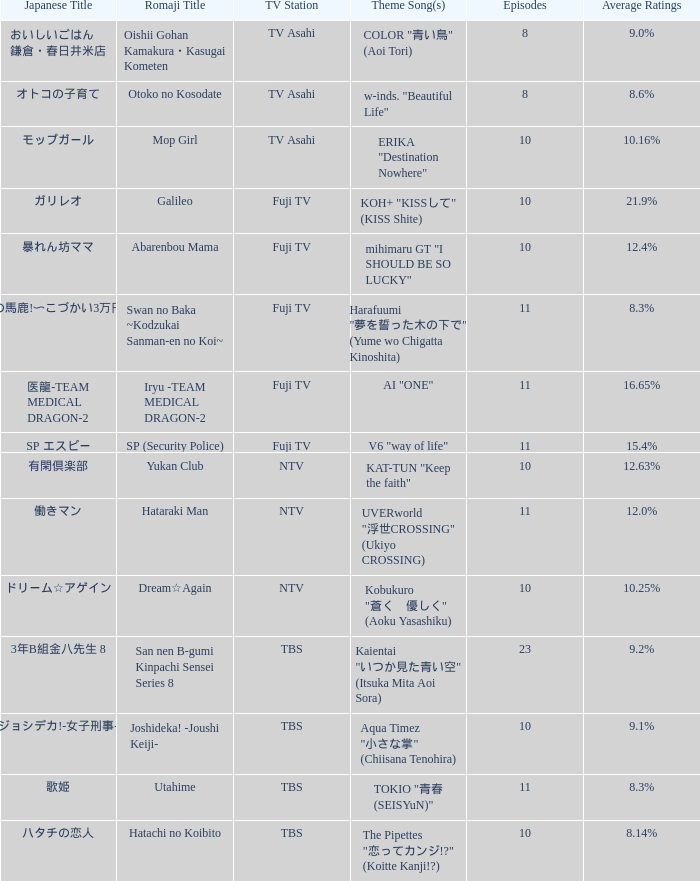Could you help me parse every detail presented in this table? {'header': ['Japanese Title', 'Romaji Title', 'TV Station', 'Theme Song(s)', 'Episodes', 'Average Ratings'], 'rows': [['おいしいごはん 鎌倉・春日井米店', 'Oishii Gohan Kamakura・Kasugai Kometen', 'TV Asahi', 'COLOR "青い鳥" (Aoi Tori)', '8', '9.0%'], ['オトコの子育て', 'Otoko no Kosodate', 'TV Asahi', 'w-inds. "Beautiful Life"', '8', '8.6%'], ['モップガール', 'Mop Girl', 'TV Asahi', 'ERIKA "Destination Nowhere"', '10', '10.16%'], ['ガリレオ', 'Galileo', 'Fuji TV', 'KOH+ "KISSして" (KISS Shite)', '10', '21.9%'], ['暴れん坊ママ', 'Abarenbou Mama', 'Fuji TV', 'mihimaru GT "I SHOULD BE SO LUCKY"', '10', '12.4%'], ['スワンの馬鹿!〜こづかい3万円の恋〜', 'Swan no Baka ~Kodzukai Sanman-en no Koi~', 'Fuji TV', 'Harafuumi "夢を誓った木の下で" (Yume wo Chigatta Kinoshita)', '11', '8.3%'], ['医龍-TEAM MEDICAL DRAGON-2', 'Iryu -TEAM MEDICAL DRAGON-2', 'Fuji TV', 'AI "ONE"', '11', '16.65%'], ['SP エスピー', 'SP (Security Police)', 'Fuji TV', 'V6 "way of life"', '11', '15.4%'], ['有閑倶楽部', 'Yukan Club', 'NTV', 'KAT-TUN "Keep the faith"', '10', '12.63%'], ['働きマン', 'Hataraki Man', 'NTV', 'UVERworld "浮世CROSSING" (Ukiyo CROSSING)', '11', '12.0%'], ['ドリーム☆アゲイン', 'Dream☆Again', 'NTV', 'Kobukuro "蒼く\u3000優しく" (Aoku Yasashiku)', '10', '10.25%'], ['3年B組金八先生 8', 'San nen B-gumi Kinpachi Sensei Series 8', 'TBS', 'Kaientai "いつか見た青い空" (Itsuka Mita Aoi Sora)', '23', '9.2%'], ['ジョシデカ!-女子刑事-', 'Joshideka! -Joushi Keiji-', 'TBS', 'Aqua Timez "小さな掌" (Chiisana Tenohira)', '10', '9.1%'], ['歌姫', 'Utahime', 'TBS', 'TOKIO "青春 (SEISYuN)"', '11', '8.3%'], ['ハタチの恋人', 'Hatachi no Koibito', 'TBS', 'The Pipettes "恋ってカンジ!?" (Koitte Kanji!?)', '10', '8.14%']]} Which song serves as the theme for the show on fuji tv station that boasts a 16.65% average rating? AI "ONE". 